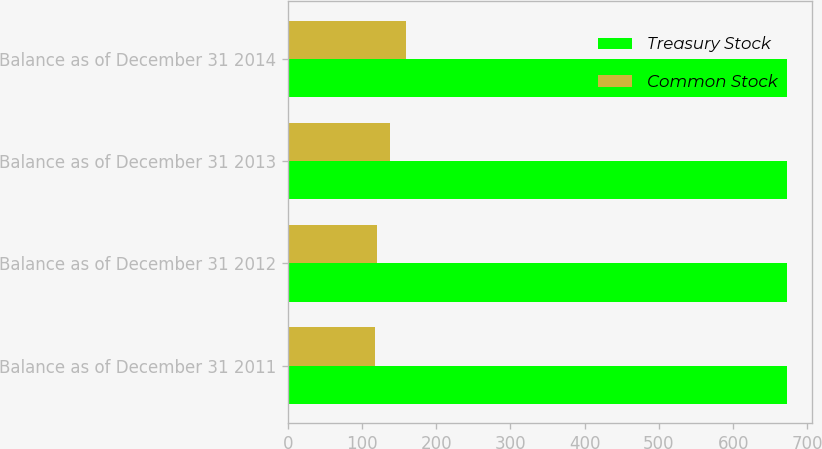Convert chart to OTSL. <chart><loc_0><loc_0><loc_500><loc_500><stacked_bar_chart><ecel><fcel>Balance as of December 31 2011<fcel>Balance as of December 31 2012<fcel>Balance as of December 31 2013<fcel>Balance as of December 31 2014<nl><fcel>Treasury Stock<fcel>673<fcel>673<fcel>673<fcel>673<nl><fcel>Common Stock<fcel>117<fcel>121<fcel>138<fcel>159<nl></chart> 